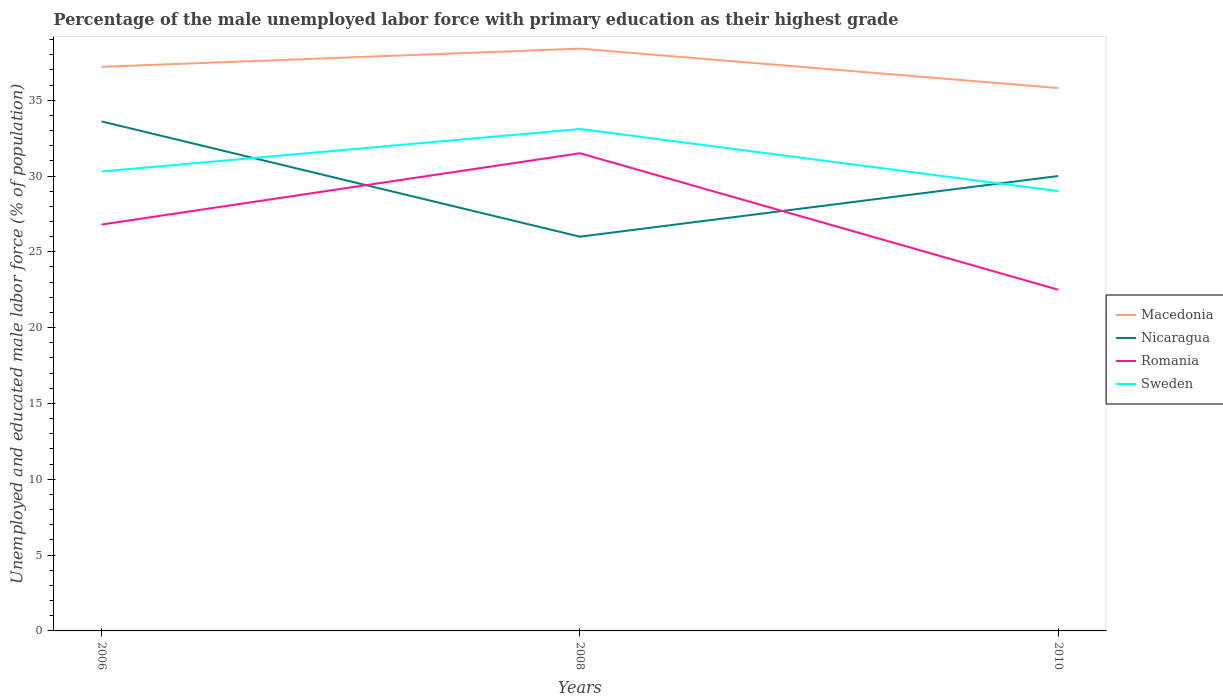How many different coloured lines are there?
Keep it short and to the point. 4. Is the number of lines equal to the number of legend labels?
Give a very brief answer. Yes. What is the total percentage of the unemployed male labor force with primary education in Romania in the graph?
Your answer should be very brief. 9. What is the difference between the highest and the second highest percentage of the unemployed male labor force with primary education in Macedonia?
Your answer should be compact. 2.6. Does the graph contain any zero values?
Provide a short and direct response. No. Does the graph contain grids?
Make the answer very short. No. How are the legend labels stacked?
Provide a short and direct response. Vertical. What is the title of the graph?
Offer a terse response. Percentage of the male unemployed labor force with primary education as their highest grade. What is the label or title of the X-axis?
Ensure brevity in your answer.  Years. What is the label or title of the Y-axis?
Provide a short and direct response. Unemployed and educated male labor force (% of population). What is the Unemployed and educated male labor force (% of population) of Macedonia in 2006?
Your answer should be compact. 37.2. What is the Unemployed and educated male labor force (% of population) in Nicaragua in 2006?
Keep it short and to the point. 33.6. What is the Unemployed and educated male labor force (% of population) in Romania in 2006?
Offer a very short reply. 26.8. What is the Unemployed and educated male labor force (% of population) of Sweden in 2006?
Provide a short and direct response. 30.3. What is the Unemployed and educated male labor force (% of population) in Macedonia in 2008?
Keep it short and to the point. 38.4. What is the Unemployed and educated male labor force (% of population) in Romania in 2008?
Ensure brevity in your answer.  31.5. What is the Unemployed and educated male labor force (% of population) of Sweden in 2008?
Provide a succinct answer. 33.1. What is the Unemployed and educated male labor force (% of population) of Macedonia in 2010?
Keep it short and to the point. 35.8. What is the Unemployed and educated male labor force (% of population) of Nicaragua in 2010?
Provide a succinct answer. 30. What is the Unemployed and educated male labor force (% of population) of Sweden in 2010?
Ensure brevity in your answer.  29. Across all years, what is the maximum Unemployed and educated male labor force (% of population) of Macedonia?
Offer a very short reply. 38.4. Across all years, what is the maximum Unemployed and educated male labor force (% of population) in Nicaragua?
Offer a terse response. 33.6. Across all years, what is the maximum Unemployed and educated male labor force (% of population) of Romania?
Your response must be concise. 31.5. Across all years, what is the maximum Unemployed and educated male labor force (% of population) in Sweden?
Provide a short and direct response. 33.1. Across all years, what is the minimum Unemployed and educated male labor force (% of population) in Macedonia?
Your response must be concise. 35.8. Across all years, what is the minimum Unemployed and educated male labor force (% of population) of Nicaragua?
Your response must be concise. 26. Across all years, what is the minimum Unemployed and educated male labor force (% of population) of Romania?
Ensure brevity in your answer.  22.5. What is the total Unemployed and educated male labor force (% of population) of Macedonia in the graph?
Provide a short and direct response. 111.4. What is the total Unemployed and educated male labor force (% of population) in Nicaragua in the graph?
Offer a terse response. 89.6. What is the total Unemployed and educated male labor force (% of population) of Romania in the graph?
Your answer should be very brief. 80.8. What is the total Unemployed and educated male labor force (% of population) in Sweden in the graph?
Your answer should be compact. 92.4. What is the difference between the Unemployed and educated male labor force (% of population) of Macedonia in 2006 and that in 2008?
Provide a short and direct response. -1.2. What is the difference between the Unemployed and educated male labor force (% of population) in Nicaragua in 2006 and that in 2008?
Your answer should be compact. 7.6. What is the difference between the Unemployed and educated male labor force (% of population) of Romania in 2006 and that in 2008?
Offer a very short reply. -4.7. What is the difference between the Unemployed and educated male labor force (% of population) in Nicaragua in 2006 and that in 2010?
Your answer should be very brief. 3.6. What is the difference between the Unemployed and educated male labor force (% of population) of Romania in 2006 and that in 2010?
Give a very brief answer. 4.3. What is the difference between the Unemployed and educated male labor force (% of population) of Macedonia in 2008 and that in 2010?
Your answer should be very brief. 2.6. What is the difference between the Unemployed and educated male labor force (% of population) in Sweden in 2008 and that in 2010?
Your answer should be compact. 4.1. What is the difference between the Unemployed and educated male labor force (% of population) in Macedonia in 2006 and the Unemployed and educated male labor force (% of population) in Nicaragua in 2008?
Ensure brevity in your answer.  11.2. What is the difference between the Unemployed and educated male labor force (% of population) in Macedonia in 2006 and the Unemployed and educated male labor force (% of population) in Sweden in 2008?
Give a very brief answer. 4.1. What is the difference between the Unemployed and educated male labor force (% of population) of Romania in 2006 and the Unemployed and educated male labor force (% of population) of Sweden in 2008?
Your response must be concise. -6.3. What is the difference between the Unemployed and educated male labor force (% of population) of Macedonia in 2006 and the Unemployed and educated male labor force (% of population) of Nicaragua in 2010?
Make the answer very short. 7.2. What is the difference between the Unemployed and educated male labor force (% of population) in Nicaragua in 2006 and the Unemployed and educated male labor force (% of population) in Romania in 2010?
Your answer should be very brief. 11.1. What is the difference between the Unemployed and educated male labor force (% of population) in Nicaragua in 2006 and the Unemployed and educated male labor force (% of population) in Sweden in 2010?
Your answer should be very brief. 4.6. What is the difference between the Unemployed and educated male labor force (% of population) in Macedonia in 2008 and the Unemployed and educated male labor force (% of population) in Nicaragua in 2010?
Provide a short and direct response. 8.4. What is the difference between the Unemployed and educated male labor force (% of population) in Macedonia in 2008 and the Unemployed and educated male labor force (% of population) in Romania in 2010?
Offer a very short reply. 15.9. What is the difference between the Unemployed and educated male labor force (% of population) in Macedonia in 2008 and the Unemployed and educated male labor force (% of population) in Sweden in 2010?
Make the answer very short. 9.4. What is the difference between the Unemployed and educated male labor force (% of population) of Nicaragua in 2008 and the Unemployed and educated male labor force (% of population) of Sweden in 2010?
Your answer should be very brief. -3. What is the average Unemployed and educated male labor force (% of population) of Macedonia per year?
Offer a very short reply. 37.13. What is the average Unemployed and educated male labor force (% of population) of Nicaragua per year?
Your answer should be very brief. 29.87. What is the average Unemployed and educated male labor force (% of population) of Romania per year?
Provide a short and direct response. 26.93. What is the average Unemployed and educated male labor force (% of population) of Sweden per year?
Offer a very short reply. 30.8. In the year 2006, what is the difference between the Unemployed and educated male labor force (% of population) of Macedonia and Unemployed and educated male labor force (% of population) of Nicaragua?
Your answer should be compact. 3.6. In the year 2006, what is the difference between the Unemployed and educated male labor force (% of population) of Macedonia and Unemployed and educated male labor force (% of population) of Romania?
Ensure brevity in your answer.  10.4. In the year 2006, what is the difference between the Unemployed and educated male labor force (% of population) of Macedonia and Unemployed and educated male labor force (% of population) of Sweden?
Provide a succinct answer. 6.9. In the year 2006, what is the difference between the Unemployed and educated male labor force (% of population) in Nicaragua and Unemployed and educated male labor force (% of population) in Romania?
Make the answer very short. 6.8. In the year 2006, what is the difference between the Unemployed and educated male labor force (% of population) in Nicaragua and Unemployed and educated male labor force (% of population) in Sweden?
Give a very brief answer. 3.3. In the year 2008, what is the difference between the Unemployed and educated male labor force (% of population) of Nicaragua and Unemployed and educated male labor force (% of population) of Sweden?
Make the answer very short. -7.1. In the year 2010, what is the difference between the Unemployed and educated male labor force (% of population) in Macedonia and Unemployed and educated male labor force (% of population) in Romania?
Your response must be concise. 13.3. In the year 2010, what is the difference between the Unemployed and educated male labor force (% of population) of Nicaragua and Unemployed and educated male labor force (% of population) of Sweden?
Give a very brief answer. 1. What is the ratio of the Unemployed and educated male labor force (% of population) of Macedonia in 2006 to that in 2008?
Your answer should be compact. 0.97. What is the ratio of the Unemployed and educated male labor force (% of population) in Nicaragua in 2006 to that in 2008?
Make the answer very short. 1.29. What is the ratio of the Unemployed and educated male labor force (% of population) in Romania in 2006 to that in 2008?
Your response must be concise. 0.85. What is the ratio of the Unemployed and educated male labor force (% of population) in Sweden in 2006 to that in 2008?
Keep it short and to the point. 0.92. What is the ratio of the Unemployed and educated male labor force (% of population) of Macedonia in 2006 to that in 2010?
Keep it short and to the point. 1.04. What is the ratio of the Unemployed and educated male labor force (% of population) in Nicaragua in 2006 to that in 2010?
Your response must be concise. 1.12. What is the ratio of the Unemployed and educated male labor force (% of population) in Romania in 2006 to that in 2010?
Offer a very short reply. 1.19. What is the ratio of the Unemployed and educated male labor force (% of population) of Sweden in 2006 to that in 2010?
Provide a succinct answer. 1.04. What is the ratio of the Unemployed and educated male labor force (% of population) of Macedonia in 2008 to that in 2010?
Offer a very short reply. 1.07. What is the ratio of the Unemployed and educated male labor force (% of population) in Nicaragua in 2008 to that in 2010?
Offer a terse response. 0.87. What is the ratio of the Unemployed and educated male labor force (% of population) in Romania in 2008 to that in 2010?
Your response must be concise. 1.4. What is the ratio of the Unemployed and educated male labor force (% of population) in Sweden in 2008 to that in 2010?
Your answer should be very brief. 1.14. What is the difference between the highest and the second highest Unemployed and educated male labor force (% of population) in Macedonia?
Your answer should be compact. 1.2. What is the difference between the highest and the second highest Unemployed and educated male labor force (% of population) in Romania?
Provide a short and direct response. 4.7. What is the difference between the highest and the second highest Unemployed and educated male labor force (% of population) in Sweden?
Offer a terse response. 2.8. What is the difference between the highest and the lowest Unemployed and educated male labor force (% of population) of Macedonia?
Ensure brevity in your answer.  2.6. What is the difference between the highest and the lowest Unemployed and educated male labor force (% of population) of Romania?
Make the answer very short. 9. 